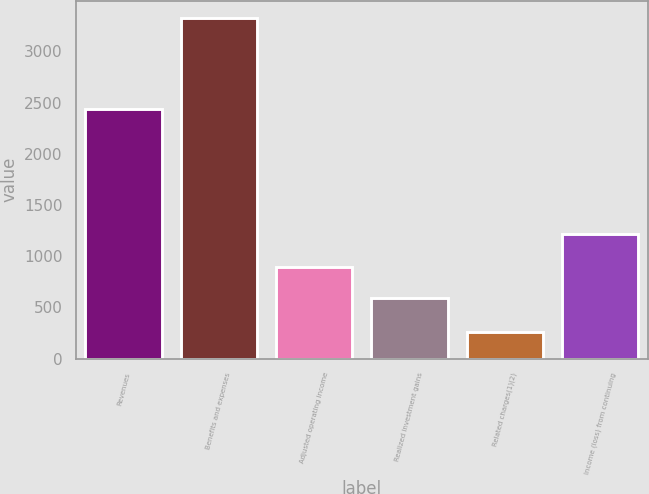Convert chart to OTSL. <chart><loc_0><loc_0><loc_500><loc_500><bar_chart><fcel>Revenues<fcel>Benefits and expenses<fcel>Adjusted operating income<fcel>Realized investment gains<fcel>Related charges(1)(2)<fcel>Income (loss) from continuing<nl><fcel>2437<fcel>3327<fcel>897.4<fcel>591<fcel>263<fcel>1218<nl></chart> 